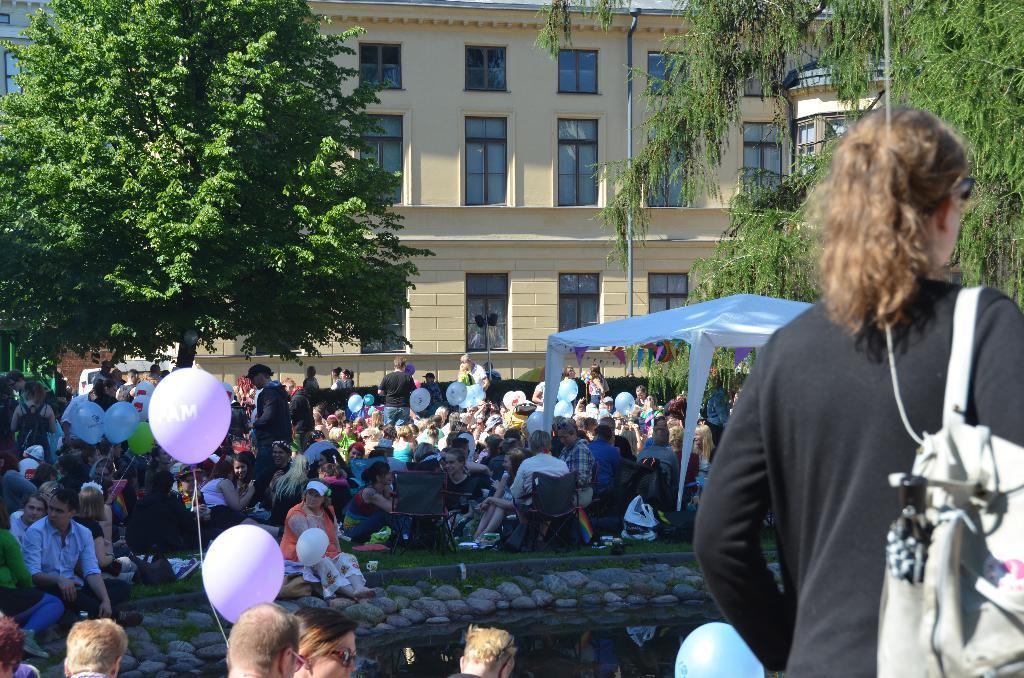Describe this image in one or two sentences. On the right side, there is a woman in black color T-shirt, wearing a bag and standing. Beside her, there is a blue color balloon. On the right side, there are two violet color balloons. Beside these two balloons, there are persons. In the background, there are stones. Beside these stones, there are persons on the ground, on which there is grass, there is a white color tent, there are trees, buildings which are having glass windows. 